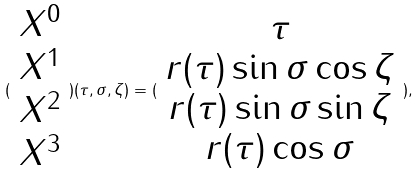<formula> <loc_0><loc_0><loc_500><loc_500>( \begin{array} { c } X ^ { 0 } \\ X ^ { 1 } \\ X ^ { 2 } \\ X ^ { 3 } \end{array} ) ( \tau , \sigma , \zeta ) = ( \begin{array} { c } \tau \\ r ( \tau ) \sin \sigma \cos \zeta \\ r ( \tau ) \sin \sigma \sin \zeta \\ r ( \tau ) \cos \sigma \end{array} ) ,</formula> 